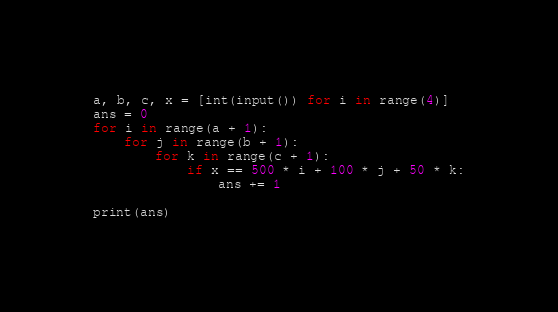Convert code to text. <code><loc_0><loc_0><loc_500><loc_500><_Python_>a, b, c, x = [int(input()) for i in range(4)]
ans = 0
for i in range(a + 1):
    for j in range(b + 1):
        for k in range(c + 1):
            if x == 500 * i + 100 * j + 50 * k:
                ans += 1

print(ans)</code> 